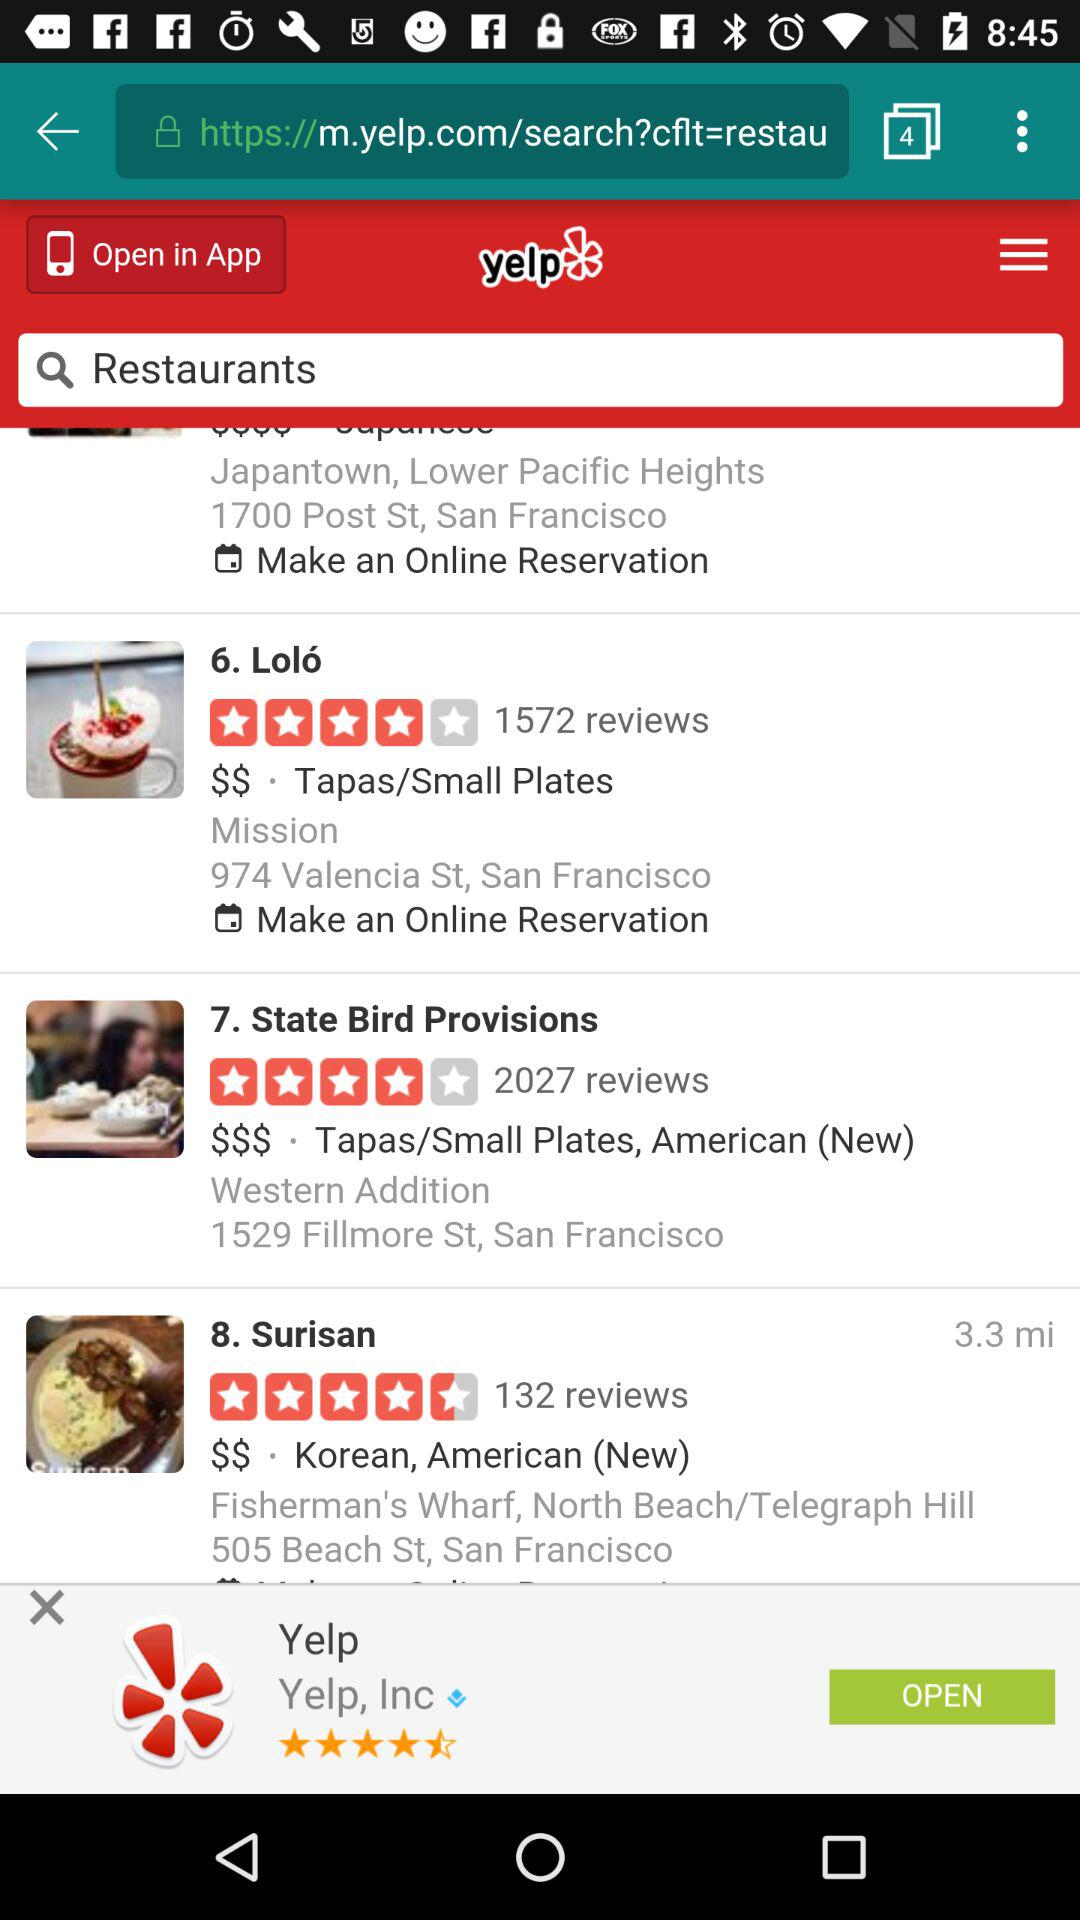How many users have rated the Surisan restaurant? There are 132 users who have rated. 